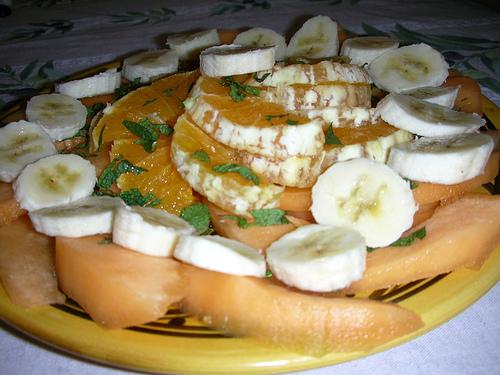What fruits are pictured?
Keep it brief. Banana, orange, cantaloupe. What is the fruit on?
Short answer required. Plate. Is there fruit in this picture?
Answer briefly. Yes. What color is the plate?
Concise answer only. Yellow. Would chocolate lover love these?
Be succinct. No. Does the fruit still have the peel on?
Quick response, please. No. How many types of fruit do you see?
Give a very brief answer. 3. Where are the bananas?
Keep it brief. On top. 